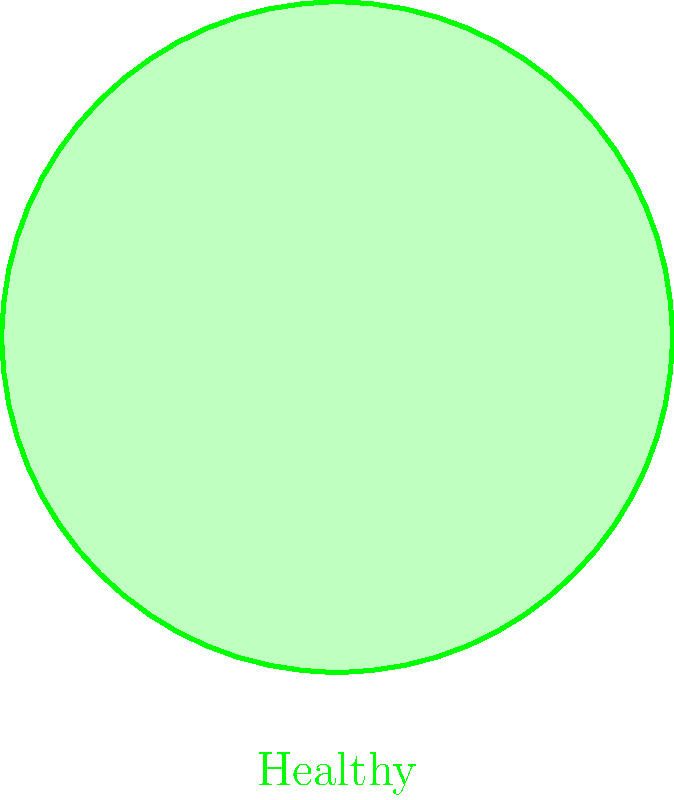In the diagram comparing a healthy organ to a failing organ, what are the two primary structural changes observed in the failing organ? To answer this question, let's analyze the diagram step-by-step:

1. The healthy organ is represented by a perfect circle, indicating a uniform structure with normal cells.

2. The failing organ, in contrast, shows an irregular shape, suggesting structural changes.

3. In the failing organ, we can observe two main differences:

   a. The presence of "Fibrosis" labeled in the upper part of the failing organ. Fibrosis is the formation of excess fibrous connective tissue, which can replace normal functional tissue.
   
   b. "Cell death" is labeled in the lower part of the failing organ. This indicates areas where cells have died and are no longer functioning.

4. These two changes - fibrosis and cell death - are common features in many types of organ failure. They lead to the irregular shape and compromised function of the failing organ.

5. The arrows pointing from the healthy organ to the failing organ emphasize these structural changes occurring during the progression of organ failure.

Therefore, the two primary structural changes observed in the failing organ are fibrosis and cell death.
Answer: Fibrosis and cell death 